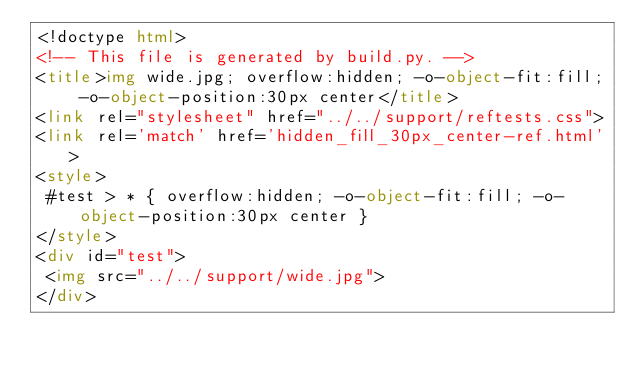Convert code to text. <code><loc_0><loc_0><loc_500><loc_500><_HTML_><!doctype html>
<!-- This file is generated by build.py. -->
<title>img wide.jpg; overflow:hidden; -o-object-fit:fill; -o-object-position:30px center</title>
<link rel="stylesheet" href="../../support/reftests.css">
<link rel='match' href='hidden_fill_30px_center-ref.html'>
<style>
 #test > * { overflow:hidden; -o-object-fit:fill; -o-object-position:30px center }
</style>
<div id="test">
 <img src="../../support/wide.jpg">
</div>
</code> 